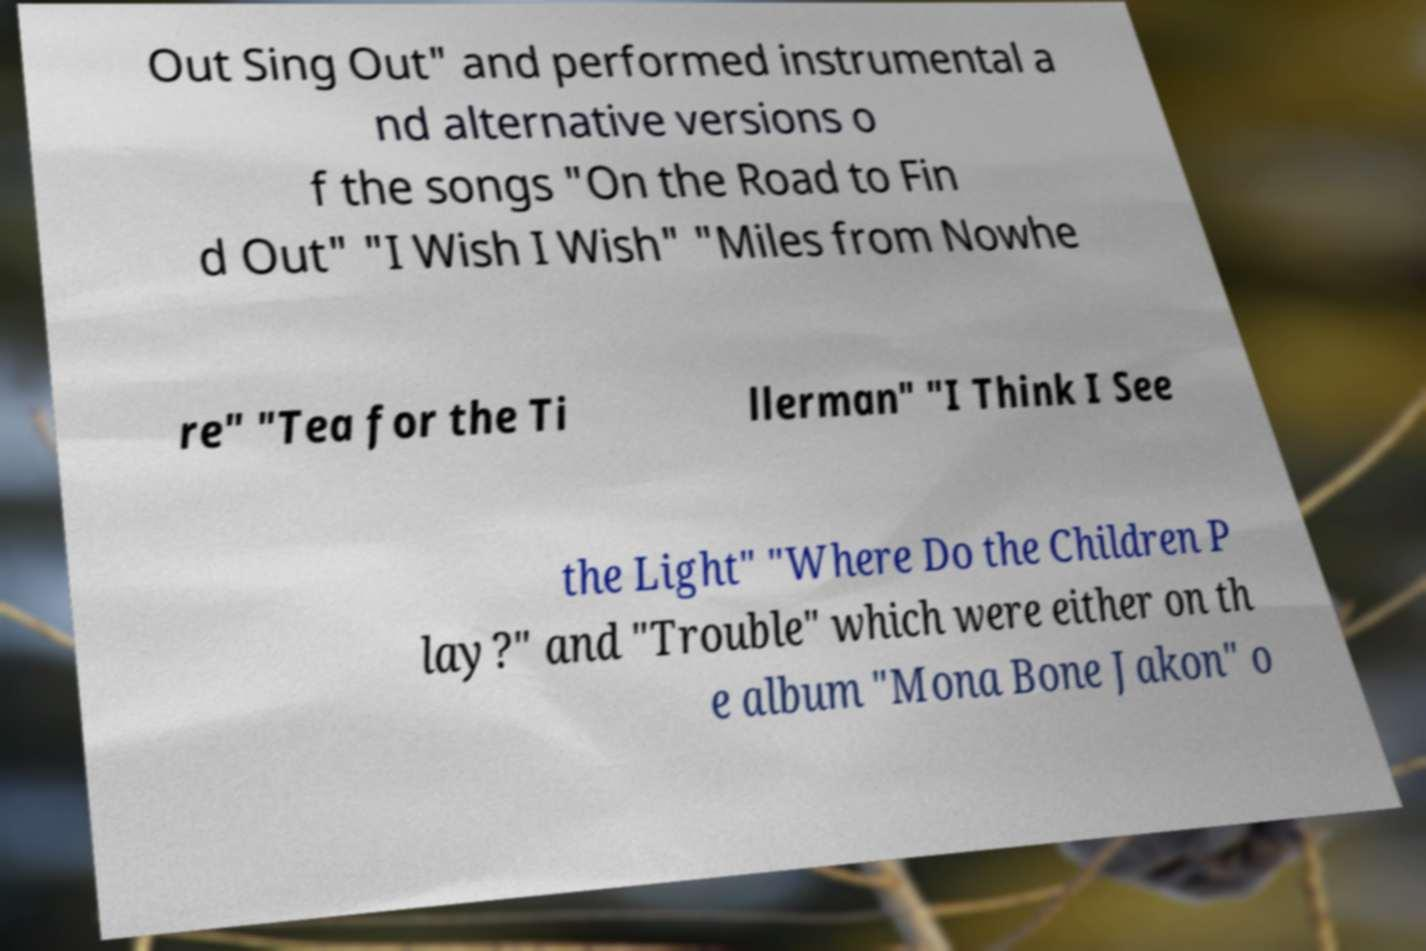Please identify and transcribe the text found in this image. Out Sing Out" and performed instrumental a nd alternative versions o f the songs "On the Road to Fin d Out" "I Wish I Wish" "Miles from Nowhe re" "Tea for the Ti llerman" "I Think I See the Light" "Where Do the Children P lay?" and "Trouble" which were either on th e album "Mona Bone Jakon" o 